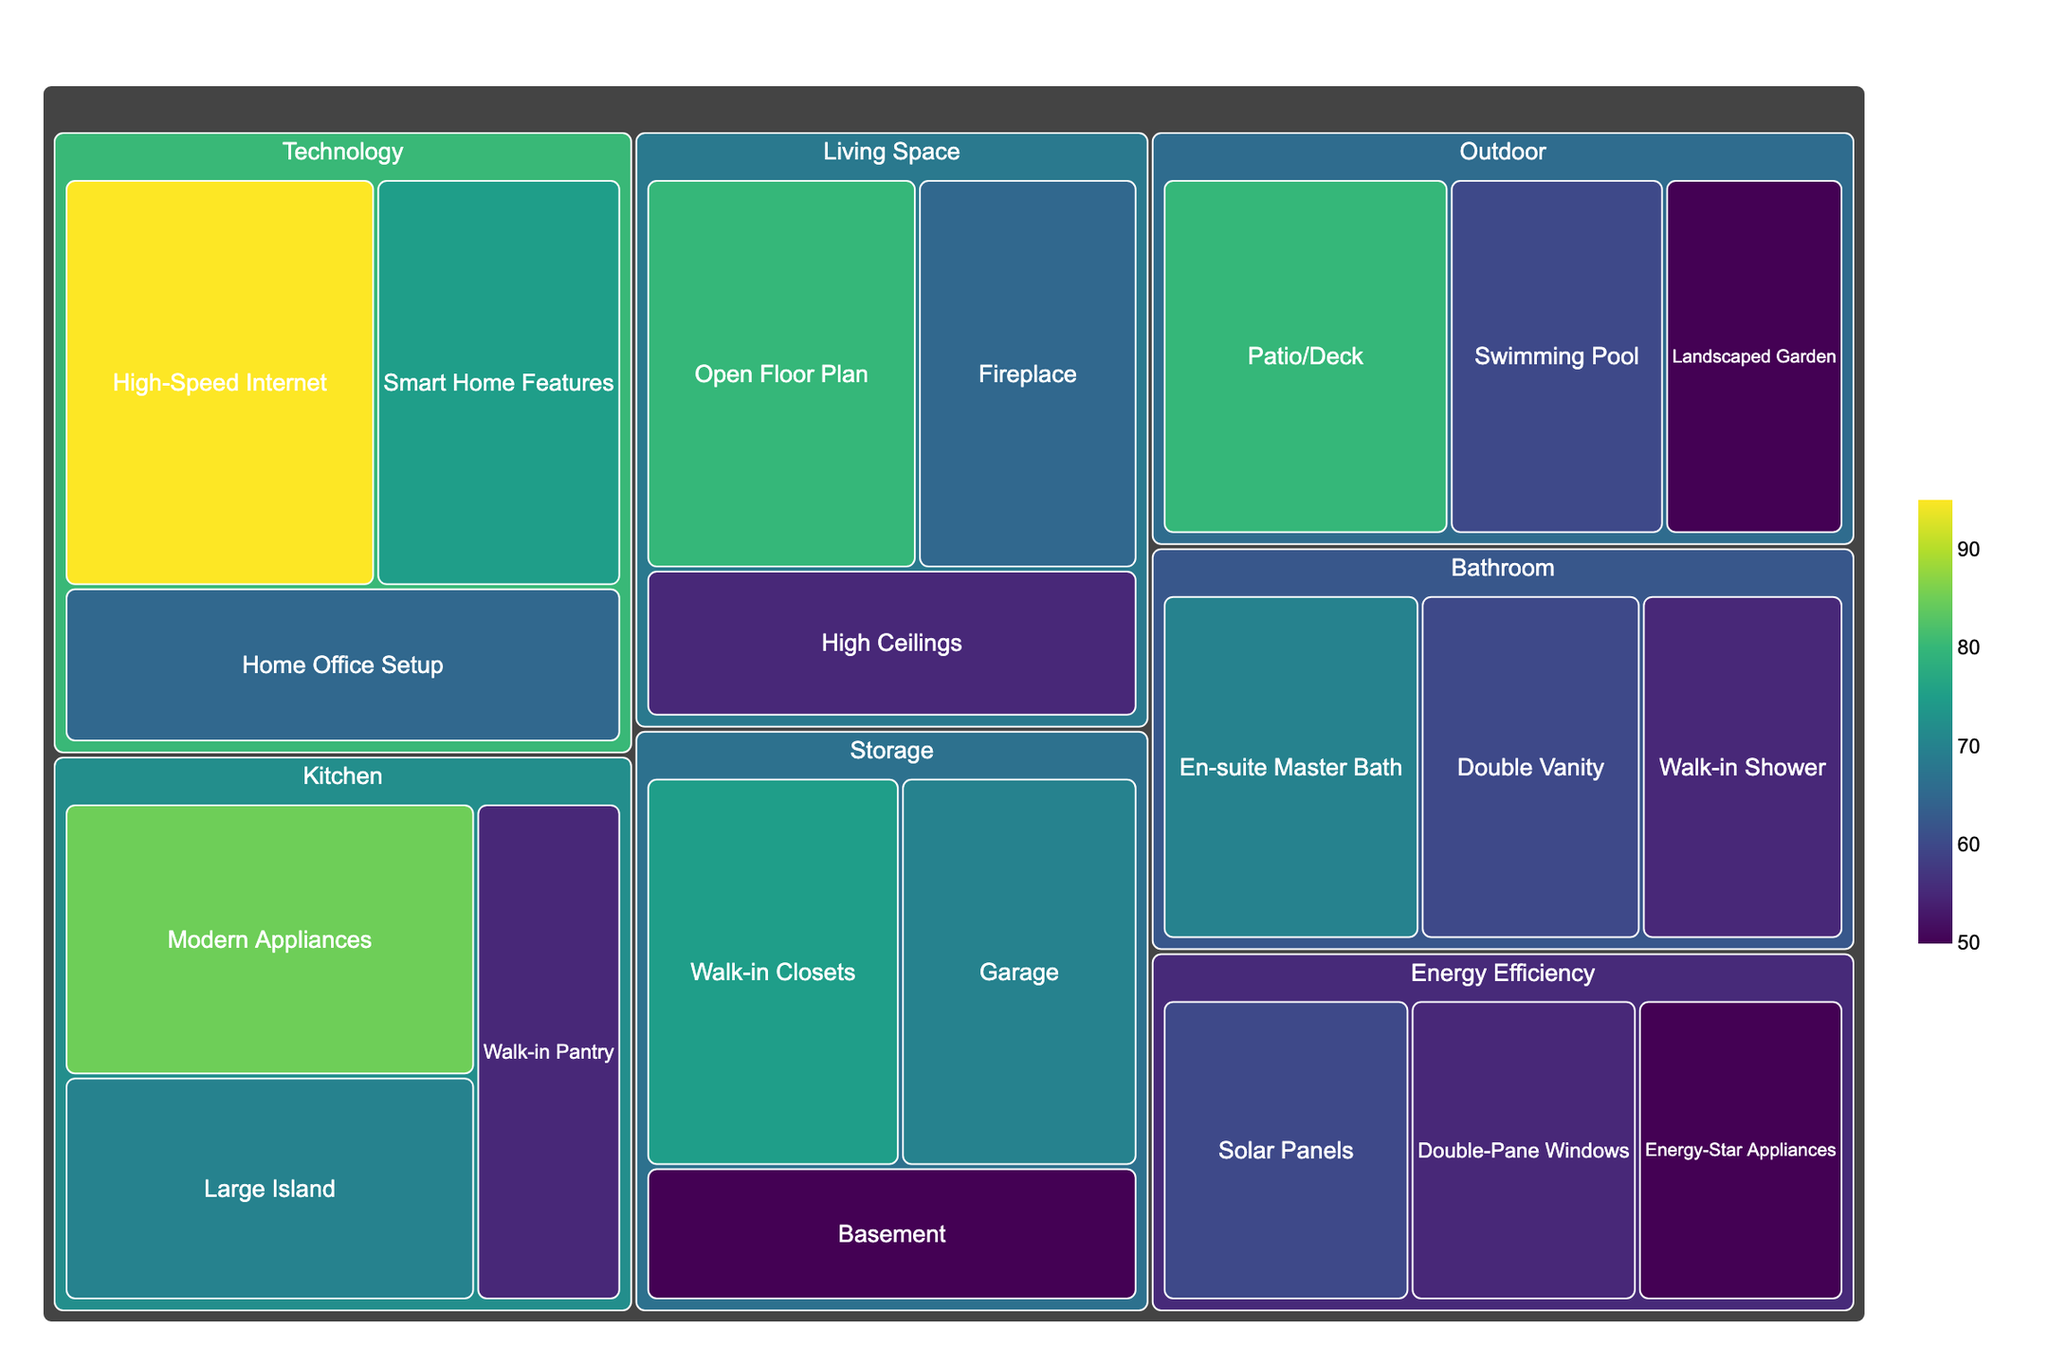What is the most popular amenity in residential properties? The treemap shows 'High-Speed Internet' under the category 'Technology' with the highest demand value of 95.
Answer: High-Speed Internet Which category has the overall highest demand when considering all its subcategories combined? Summing up the demands of all subcategories within each category: Kitchen (85 + 70 + 55 = 210), Outdoor (80 + 60 + 50 = 190), Technology (95 + 75 + 65 = 235), Bathroom (70 + 60 + 55 = 185), Living Space (80 + 65 + 55 = 200), Storage (75 + 70 + 50 = 195), Energy Efficiency (60 + 55 + 50 = 165). Technology has the highest combined demand.
Answer: Technology What is the least demanded subcategory in Bathroom? The subcategory 'Walk-in Shower' in the Bathroom has the lowest demand value of 55.
Answer: Walk-in Shower How does the demand for 'Smart Home Features' compare to 'Fireplace'? 'Smart Home Features' has a demand of 75, while 'Fireplace' has a demand of 65. The demand for 'Smart Home Features' is higher.
Answer: Smart Home Features Which subcategories have the same demand value across any categories? The demand value of 55 is shared by 'Walk-in Pantry' (Kitchen), 'Walk-in Shower' (Bathroom), 'High Ceilings' (Living Space), 'Double-Pane Windows' (Energy Efficiency), and 'Energy-Star Appliances' (Energy Efficiency).
Answer: Walk-in Pantry, Walk-in Shower, High Ceilings, Double-Pane Windows, Energy-Star Appliances What is the average demand for subcategories in the 'Living Space' category? The demand for each subcategory in Living Space is 80, 65, and 55. Summing them up gives 200. Dividing by the number of subcategories (3), the average demand is 200 / 3 ≈ 66.67.
Answer: ≈ 66.67 Are there more high-demand amenities (above 70) or low-demand amenities (70 and below)? Counting demands above 70: 85, 80, 75, 95. Counting demands 70 or below: 70, 55, 60, 50, 70, 55, 65, 55, 75, 70, 50, 60, 55, 50. There are 4 high-demand and 14 low-demand amenities. There are more low-demand amenities.
Answer: Low-demand amenities What proportion of the total demand does the subcategory 'Solar Panels' represent in the Energy Efficiency category? In Energy Efficiency, the total demand is (60 + 55 + 50) = 165. The demand for 'Solar Panels' is 60. The proportion is 60 / 165 ≈ 0.36.
Answer: ≈ 0.36 Which is more popular, 'Landscaped Garden' or 'Modern Appliances'? 'Landscaped Garden' has a demand of 50, while 'Modern Appliances' has a demand of 85. 'Modern Appliances' is more popular.
Answer: Modern Appliances 